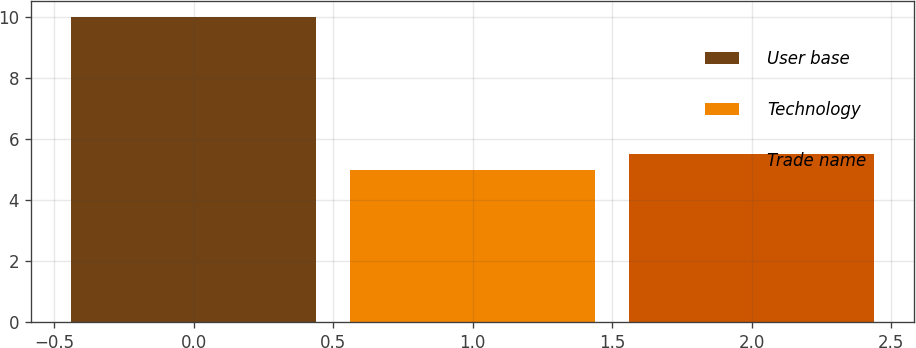Convert chart to OTSL. <chart><loc_0><loc_0><loc_500><loc_500><bar_chart><fcel>User base<fcel>Technology<fcel>Trade name<nl><fcel>10<fcel>5<fcel>5.5<nl></chart> 